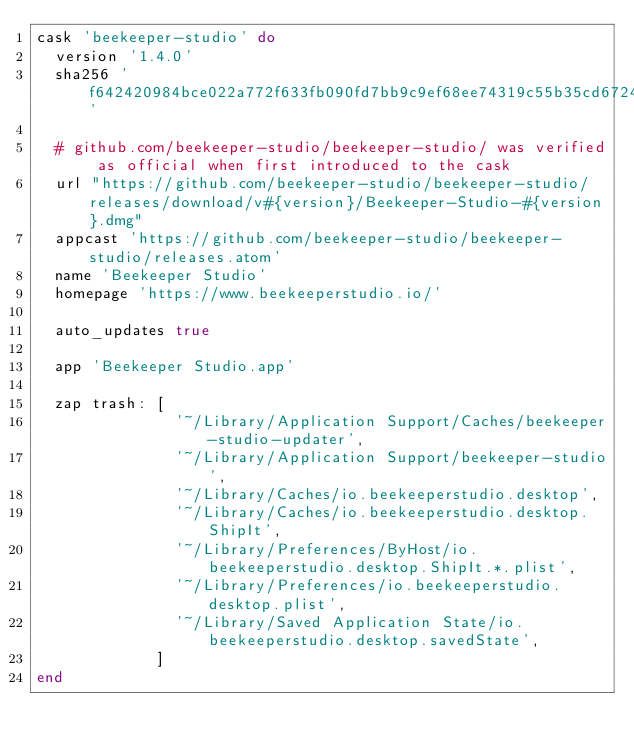<code> <loc_0><loc_0><loc_500><loc_500><_Ruby_>cask 'beekeeper-studio' do
  version '1.4.0'
  sha256 'f642420984bce022a772f633fb090fd7bb9c9ef68ee74319c55b35cd6724ba11'

  # github.com/beekeeper-studio/beekeeper-studio/ was verified as official when first introduced to the cask
  url "https://github.com/beekeeper-studio/beekeeper-studio/releases/download/v#{version}/Beekeeper-Studio-#{version}.dmg"
  appcast 'https://github.com/beekeeper-studio/beekeeper-studio/releases.atom'
  name 'Beekeeper Studio'
  homepage 'https://www.beekeeperstudio.io/'

  auto_updates true

  app 'Beekeeper Studio.app'

  zap trash: [
               '~/Library/Application Support/Caches/beekeeper-studio-updater',
               '~/Library/Application Support/beekeeper-studio',
               '~/Library/Caches/io.beekeeperstudio.desktop',
               '~/Library/Caches/io.beekeeperstudio.desktop.ShipIt',
               '~/Library/Preferences/ByHost/io.beekeeperstudio.desktop.ShipIt.*.plist',
               '~/Library/Preferences/io.beekeeperstudio.desktop.plist',
               '~/Library/Saved Application State/io.beekeeperstudio.desktop.savedState',
             ]
end
</code> 